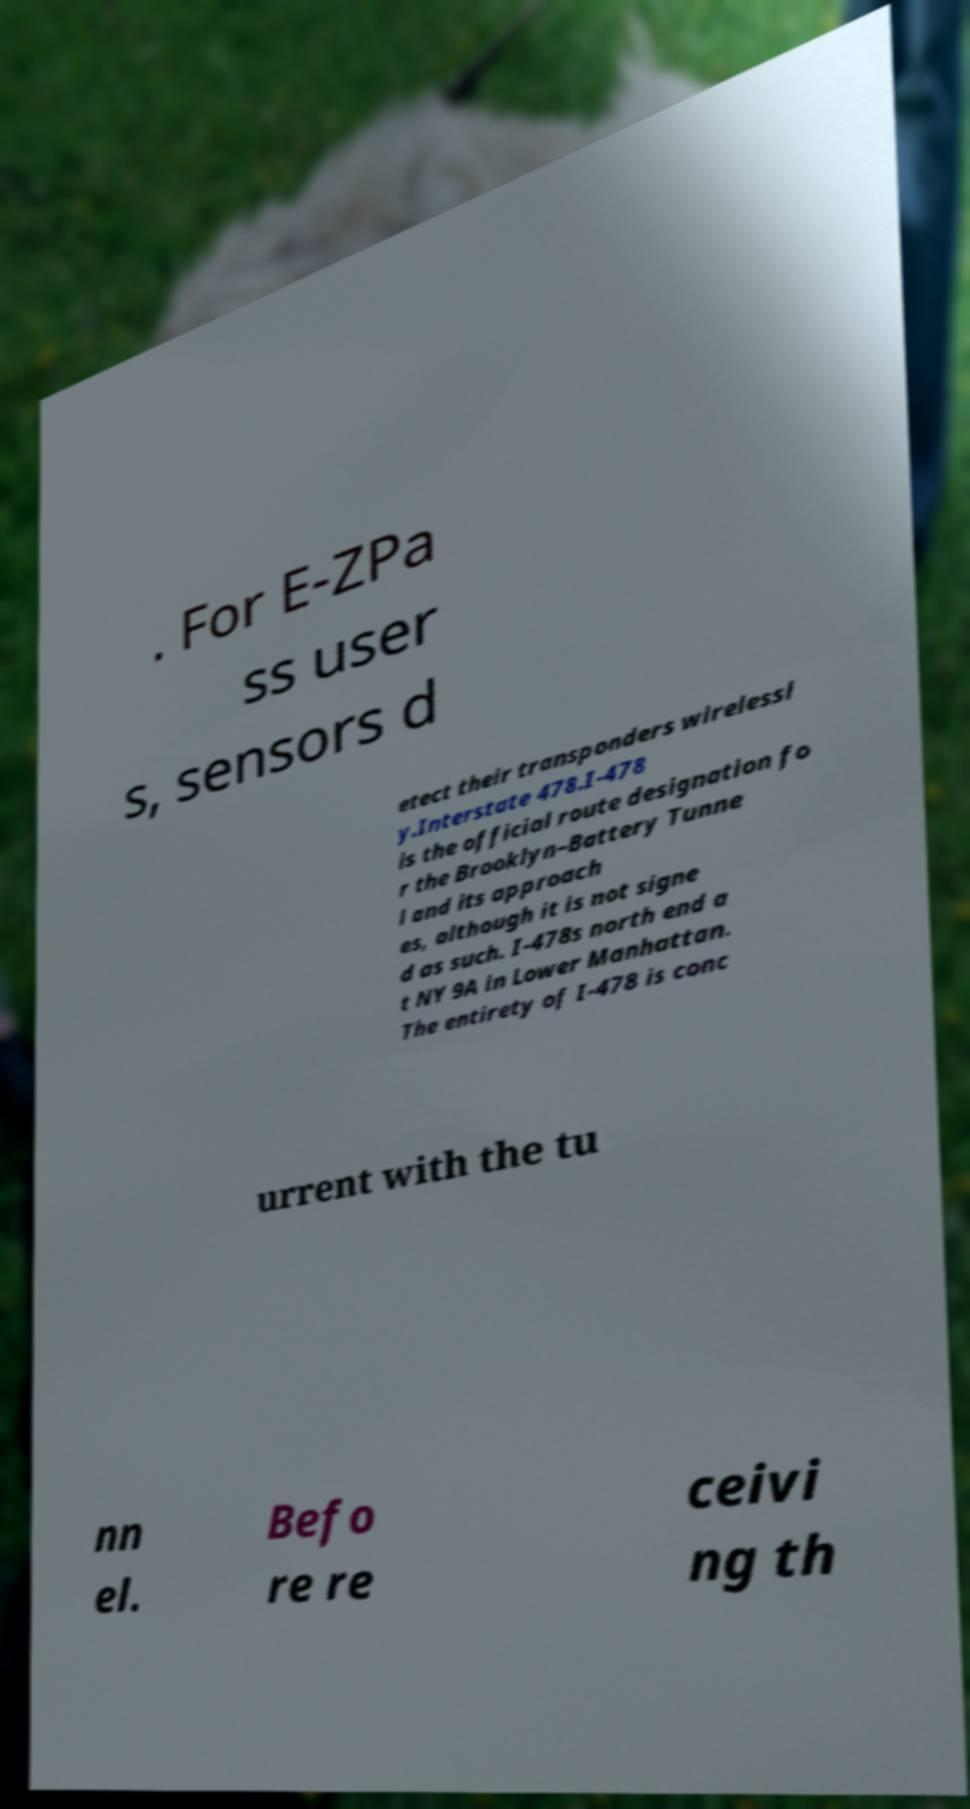Could you assist in decoding the text presented in this image and type it out clearly? . For E-ZPa ss user s, sensors d etect their transponders wirelessl y.Interstate 478.I-478 is the official route designation fo r the Brooklyn–Battery Tunne l and its approach es, although it is not signe d as such. I-478s north end a t NY 9A in Lower Manhattan. The entirety of I-478 is conc urrent with the tu nn el. Befo re re ceivi ng th 